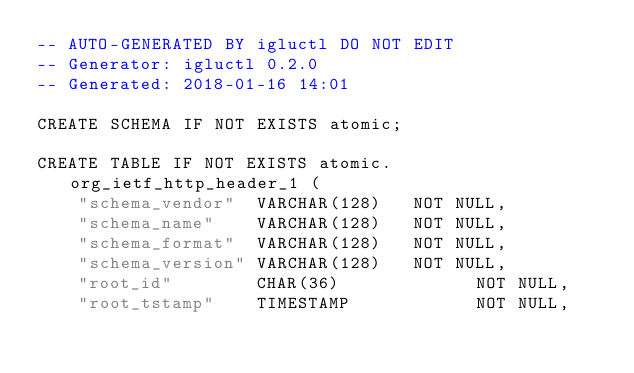Convert code to text. <code><loc_0><loc_0><loc_500><loc_500><_SQL_>-- AUTO-GENERATED BY igluctl DO NOT EDIT
-- Generator: igluctl 0.2.0
-- Generated: 2018-01-16 14:01

CREATE SCHEMA IF NOT EXISTS atomic;

CREATE TABLE IF NOT EXISTS atomic.org_ietf_http_header_1 (
    "schema_vendor"  VARCHAR(128)   NOT NULL,
    "schema_name"    VARCHAR(128)   NOT NULL,
    "schema_format"  VARCHAR(128)   NOT NULL,
    "schema_version" VARCHAR(128)   NOT NULL,
    "root_id"        CHAR(36)             NOT NULL,
    "root_tstamp"    TIMESTAMP            NOT NULL,</code> 